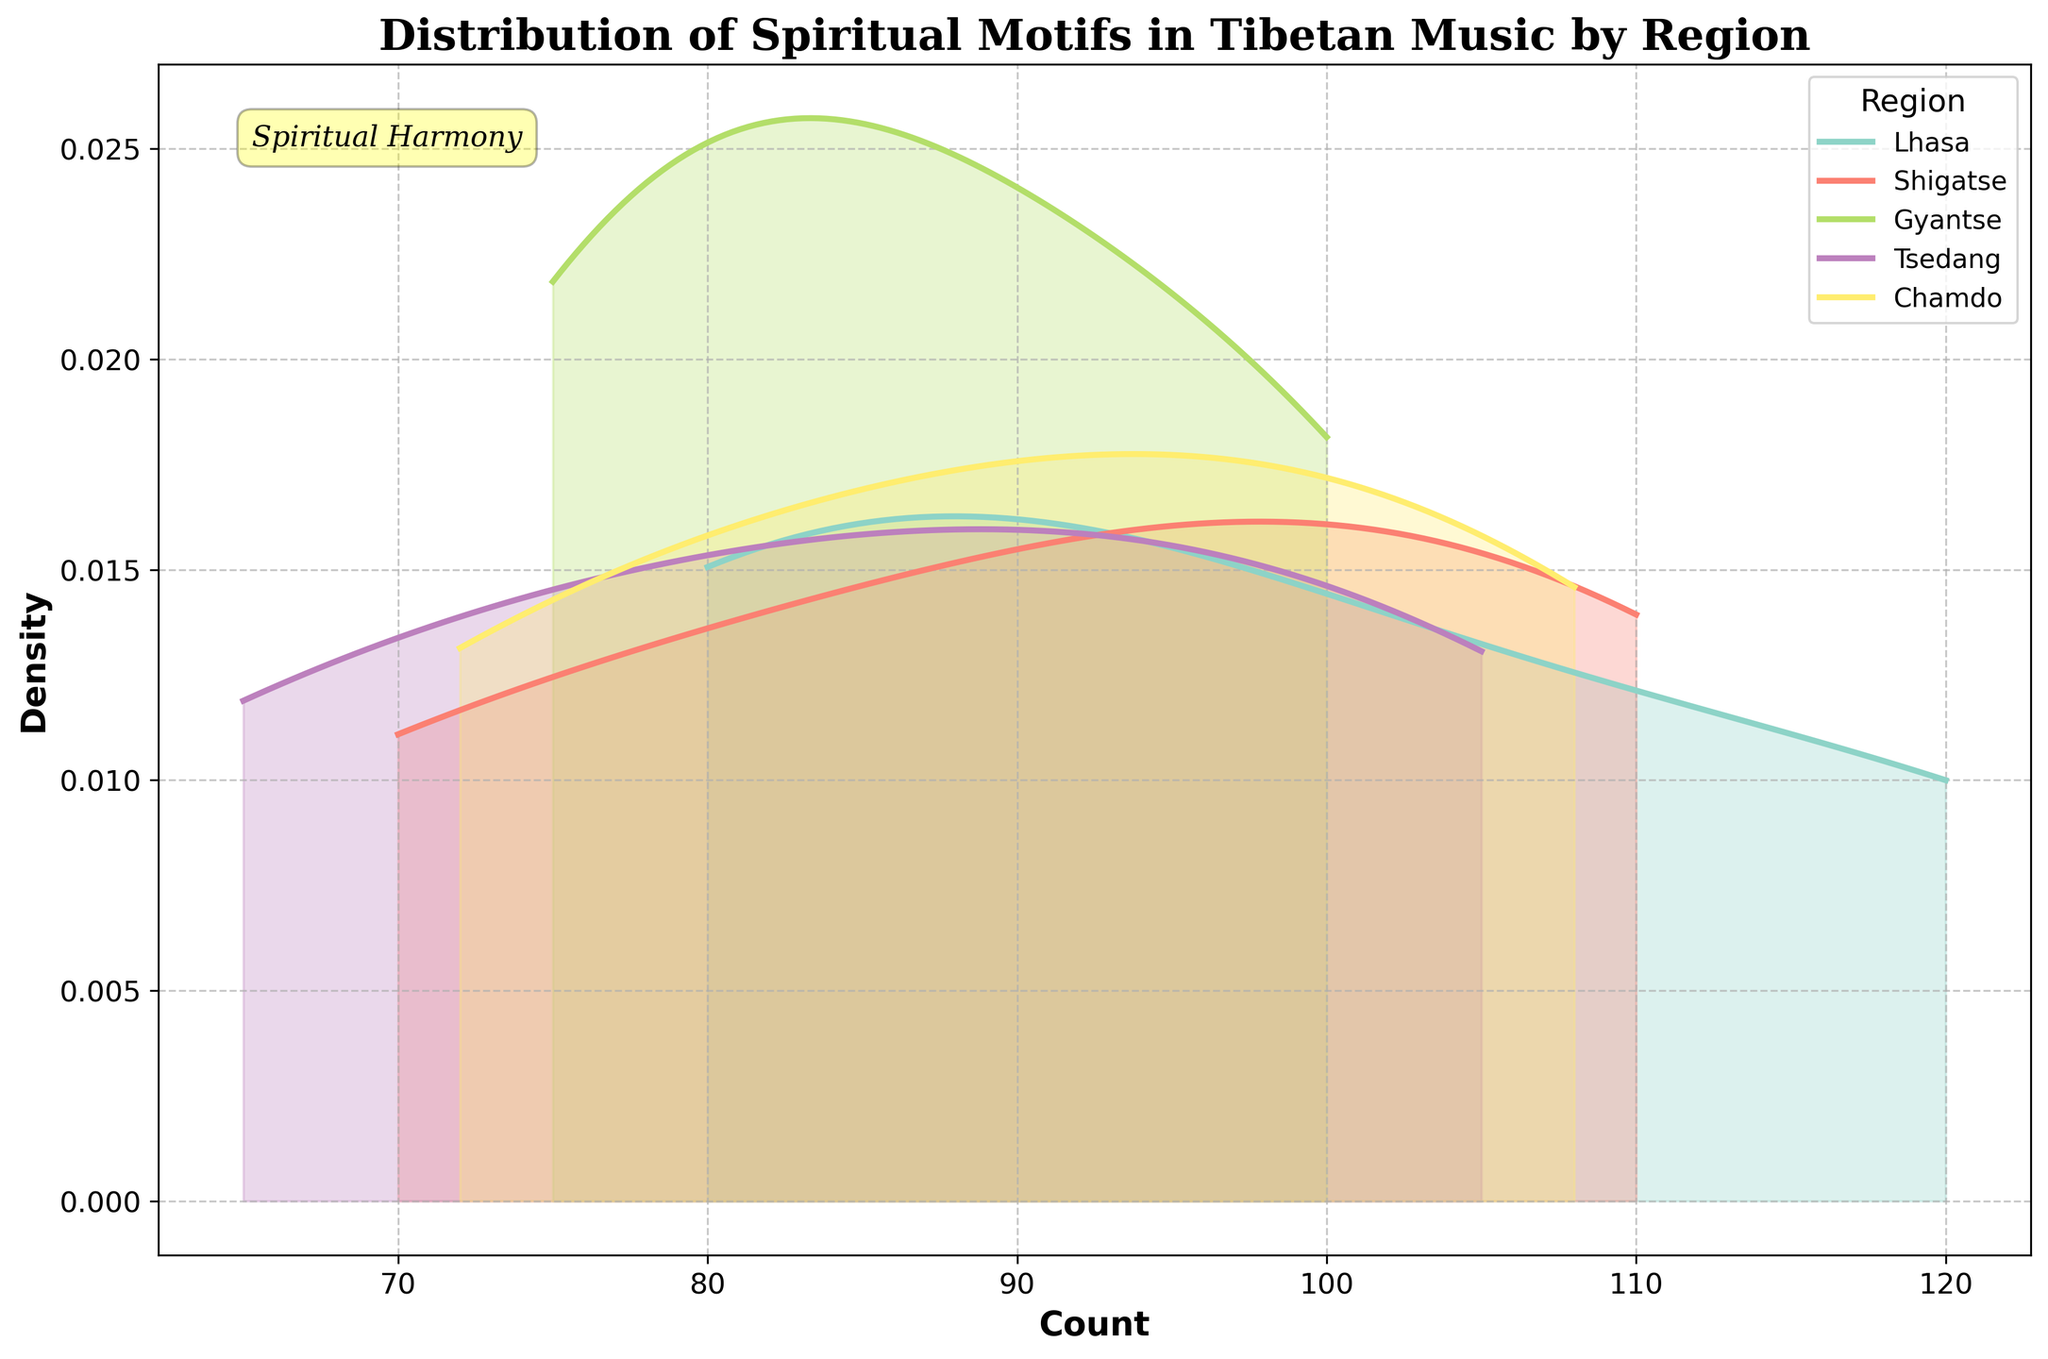What is the title of the plot? The title of any plot is typically located at the top of the figure. Here, it's prominently displayed in a bold and larger font size for easy identification.
Answer: Distribution of Spiritual Motifs in Tibetan Music by Region What regions are compared in this density plot? Observing the legend on the plot, which usually provides information about different categories, helps us identify that the regions Lhasa, Shigatse, Gyantse, Tsedang, and Chamdo are being compared.
Answer: Lhasa, Shigatse, Gyantse, Tsedang, Chamdo Which region has the highest peak density? To determine this, we look at the plot for the peak that reaches the highest point on the y-axis. The region with the highest density will have the most prominent peak.
Answer: Lhasa Which spiritual motif has the highest density in Shigatse? We need to identify peaks corresponding to Shigatse by looking at the legend for its color coding and then trace back to see which motif corresponds to the highest density for the Shigatse curve.
Answer: Chanting Between which range do most densities lie for all regions? By examining the x-axis, we can find the common range where most of the density peaks appear, indicating where the majority of values are concentrated.
Answer: Between 60 and 120 Which region has the widest spread of spiritual motif counts? The region with the widest range on the x-axis will have the broadest distribution of counts. This can be identified by looking at how far the density curves extend on the x-axis.
Answer: Lhasa Which region has the narrowest spread of densities? The region with the narrowest range on the x-axis will have the most compact distribution. This can be assessed by observing the density curve that covers the smallest range.
Answer: Tsedang What is the approximate count where Lhasa and Shigatse densities overlap the most? By examining where the density curves for Lhasa and Shigatse intersect and have the highest overlapping density, we can approximate this value by matching it to the x-axis.
Answer: Around 90 Do any motifs appear uniquely in a single region? To answer this, one must identify any peaks in the density curves that do not overlap with others and ensure it's specific to one region only. Comparing all motifs, it appears only in one region for a distinct color.
Answer: Yes, Thangka Rituals in Shigatse, Prayer Flags in Gyantse, Mudras in Tsedang, and Buddhist Ceremonies in Chamdo 